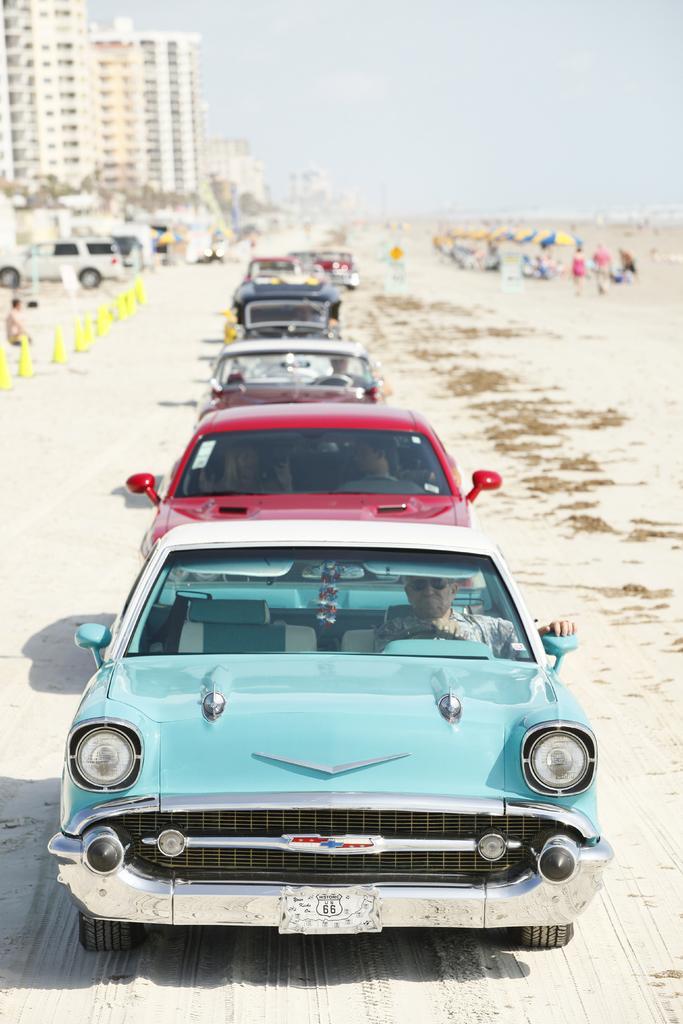Describe this image in one or two sentences. In the middle of the picture we can see many cars. On the left there are people and sand. On the right there are people, umbrella, sand and it is looking like a beach. At the top left corner there are buildings and trees. At the top it is sky. 